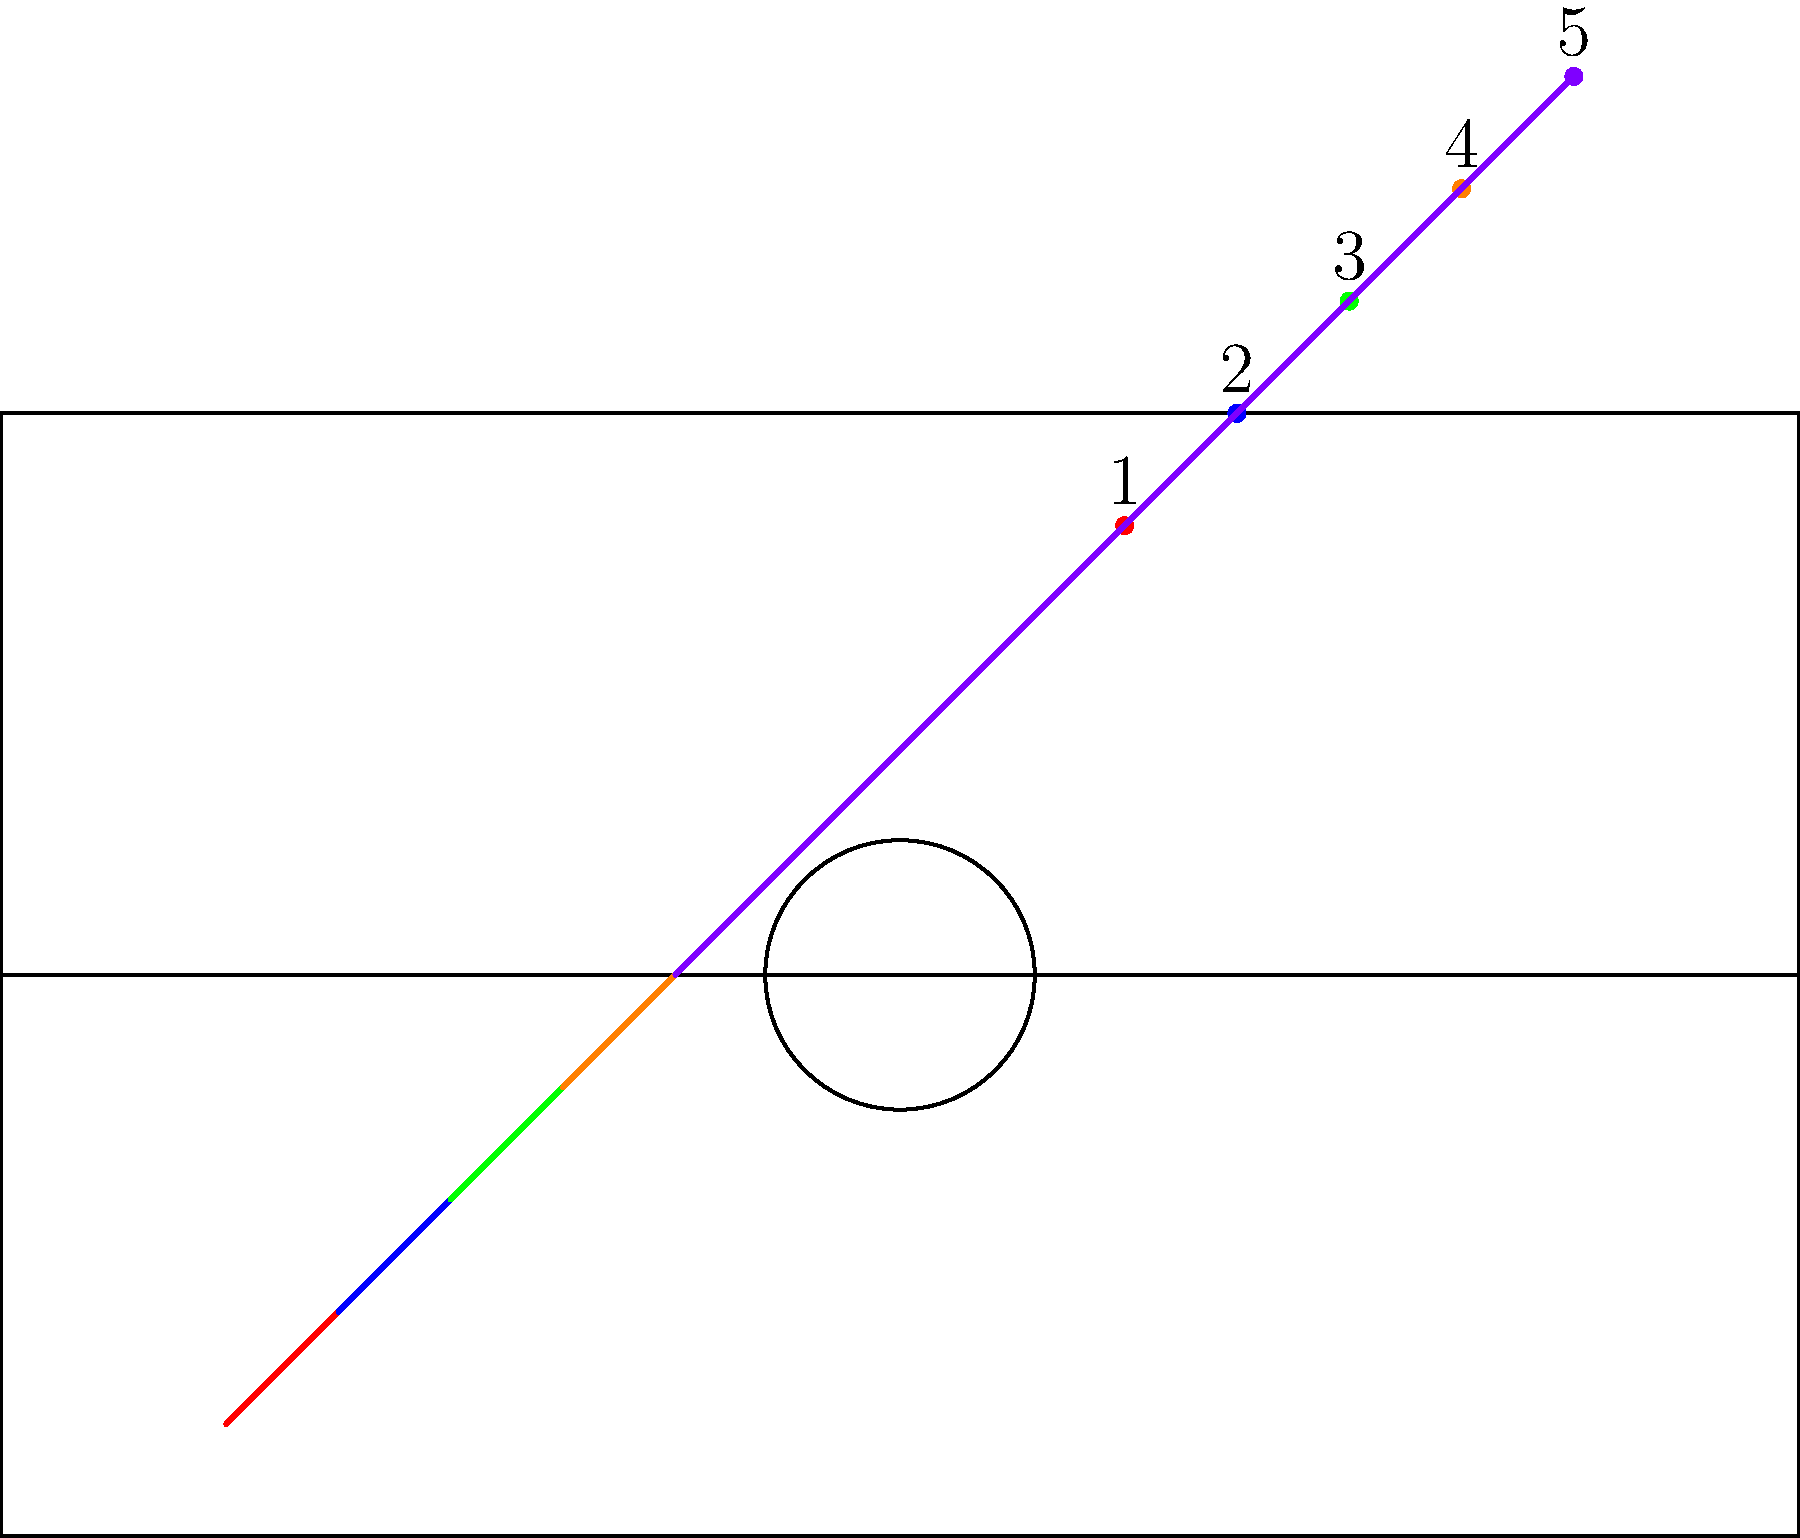Based on the player movement trajectories shown in the court diagram, which offensive strategy is most likely being employed by this BNXT League team? To determine the offensive strategy, let's analyze the player movement patterns:

1. All five players are moving from the defensive end (bottom) to the offensive end (top) of the court.

2. The players are spread out across the width of the court, maintaining spacing.

3. Players 1 and 2 (red and blue) are moving towards the corners, likely to spread the defense.

4. Player 3 (green) is moving straight up the middle, possibly setting a high screen or preparing for a pick and roll.

5. Players 4 and 5 (orange and purple) are moving towards the wings, creating space in the paint.

6. The overall pattern shows a gradual convergence towards the three-point line and beyond.

This movement pattern is consistent with a "5-out" or "five-out" offense, which is becoming increasingly popular in modern basketball. In this strategy:

- All five players start outside the three-point line, maximizing spacing.
- It creates driving lanes for penetration.
- It allows for easy kick-out passes to shooters.
- It can be effective against teams that struggle to defend in space.

The 5-out offense is particularly useful for teams with good shooters and versatile big men who can operate effectively from the perimeter, which is becoming more common in European leagues like the BNXT.
Answer: 5-out offense 